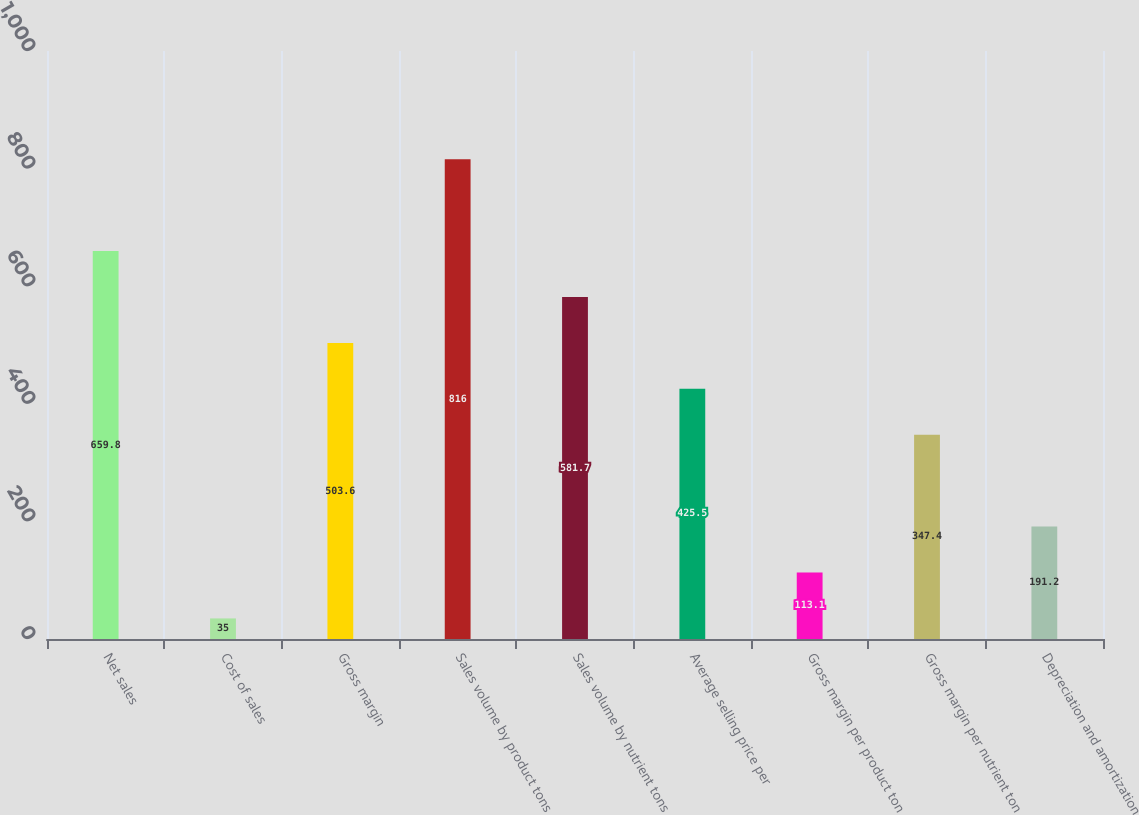Convert chart. <chart><loc_0><loc_0><loc_500><loc_500><bar_chart><fcel>Net sales<fcel>Cost of sales<fcel>Gross margin<fcel>Sales volume by product tons<fcel>Sales volume by nutrient tons<fcel>Average selling price per<fcel>Gross margin per product ton<fcel>Gross margin per nutrient ton<fcel>Depreciation and amortization<nl><fcel>659.8<fcel>35<fcel>503.6<fcel>816<fcel>581.7<fcel>425.5<fcel>113.1<fcel>347.4<fcel>191.2<nl></chart> 